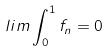Convert formula to latex. <formula><loc_0><loc_0><loc_500><loc_500>l i m \int _ { 0 } ^ { 1 } f _ { n } = 0</formula> 